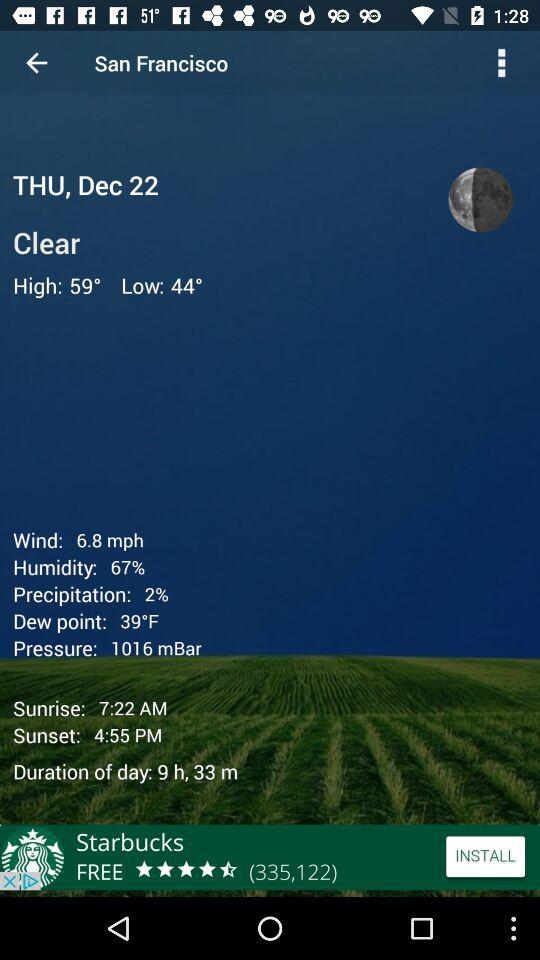What is the percentage of humidity?
Answer the question using a single word or phrase. 67% 